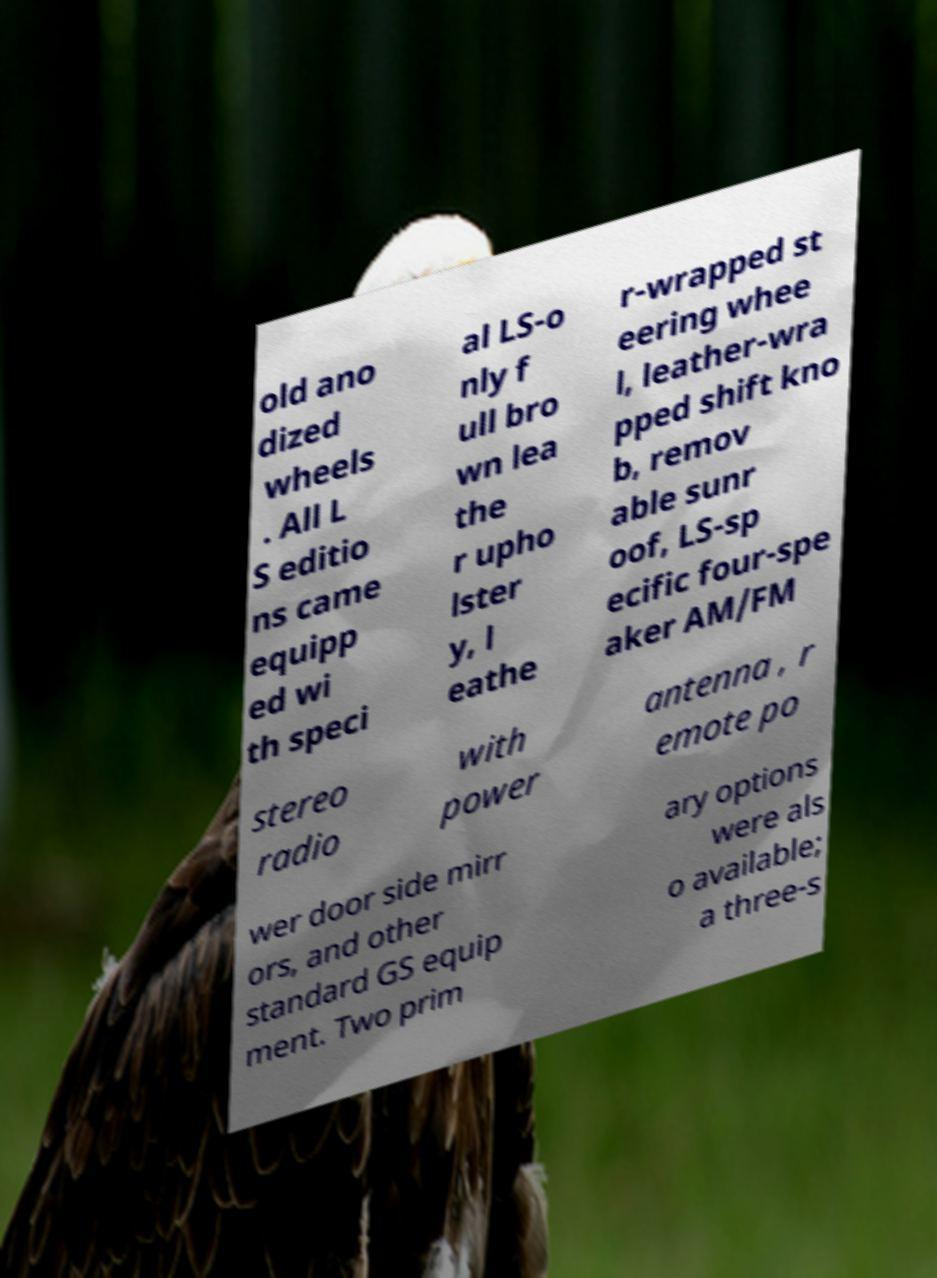Could you extract and type out the text from this image? old ano dized wheels . All L S editio ns came equipp ed wi th speci al LS-o nly f ull bro wn lea the r upho lster y, l eathe r-wrapped st eering whee l, leather-wra pped shift kno b, remov able sunr oof, LS-sp ecific four-spe aker AM/FM stereo radio with power antenna , r emote po wer door side mirr ors, and other standard GS equip ment. Two prim ary options were als o available; a three-s 